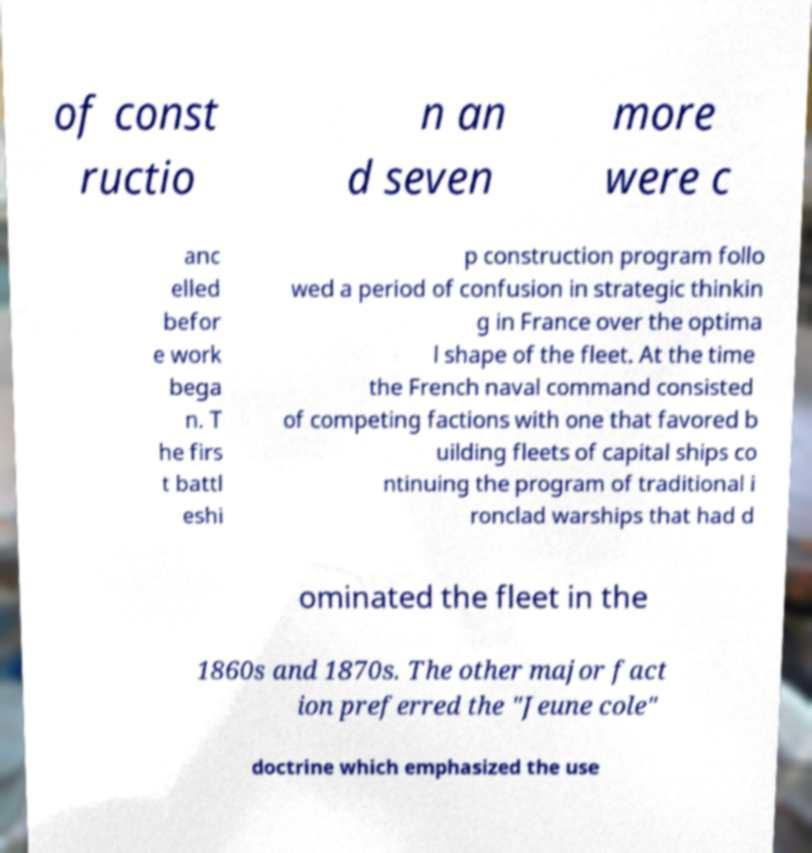There's text embedded in this image that I need extracted. Can you transcribe it verbatim? of const ructio n an d seven more were c anc elled befor e work bega n. T he firs t battl eshi p construction program follo wed a period of confusion in strategic thinkin g in France over the optima l shape of the fleet. At the time the French naval command consisted of competing factions with one that favored b uilding fleets of capital ships co ntinuing the program of traditional i ronclad warships that had d ominated the fleet in the 1860s and 1870s. The other major fact ion preferred the "Jeune cole" doctrine which emphasized the use 